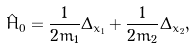<formula> <loc_0><loc_0><loc_500><loc_500>\hat { H } _ { 0 } = \frac { 1 } { 2 m _ { 1 } } \Delta _ { x _ { 1 } } + \frac { 1 } { 2 m _ { 2 } } \Delta _ { x _ { 2 } } ,</formula> 